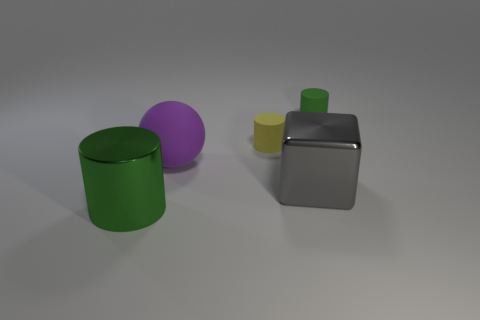There is a thing that is the same size as the yellow rubber cylinder; what is its shape? The object that is approximately the same size as the yellow rubber cylinder is the purple sphere. It shares a similar dimension but differs in shape, being a perfect three-dimensional round figure, compared to the cylindrical form of the yellow object. 